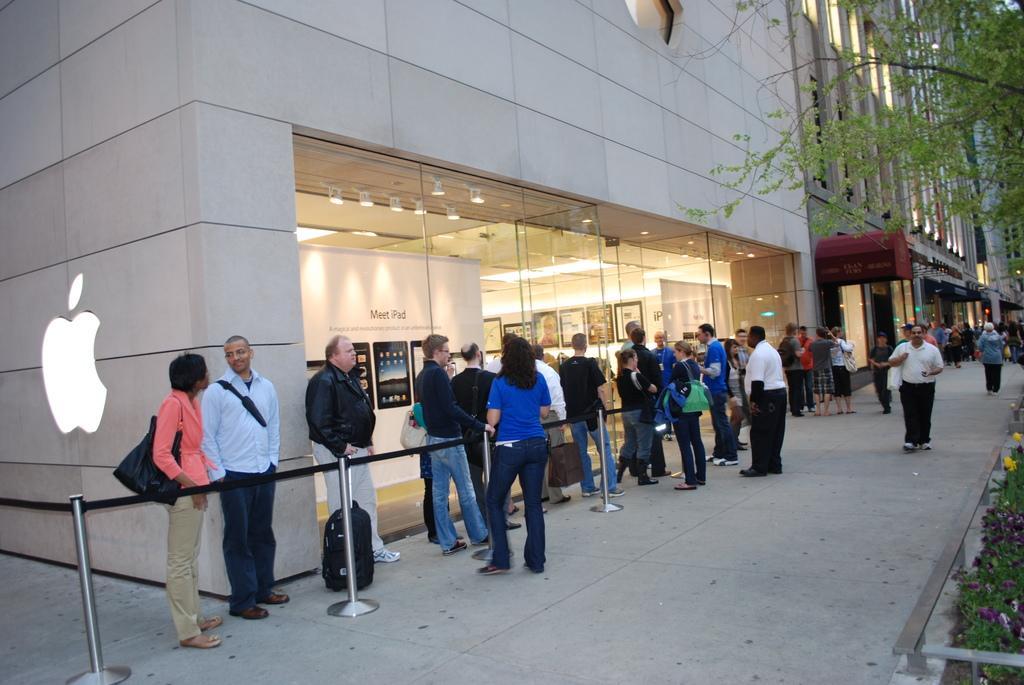Could you give a brief overview of what you see in this image? There are people, buildings and a tree in the image. 